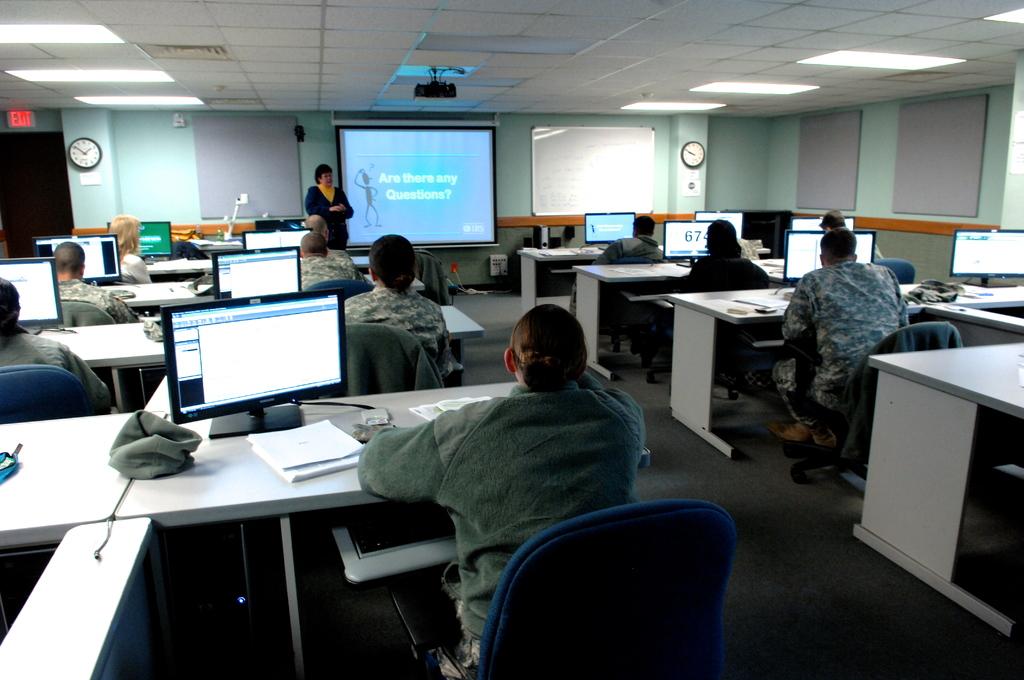What does the board at the front of the room say?
Your answer should be compact. Are there any questions?. What number can be seen on one of the monitors?
Make the answer very short. 67. 